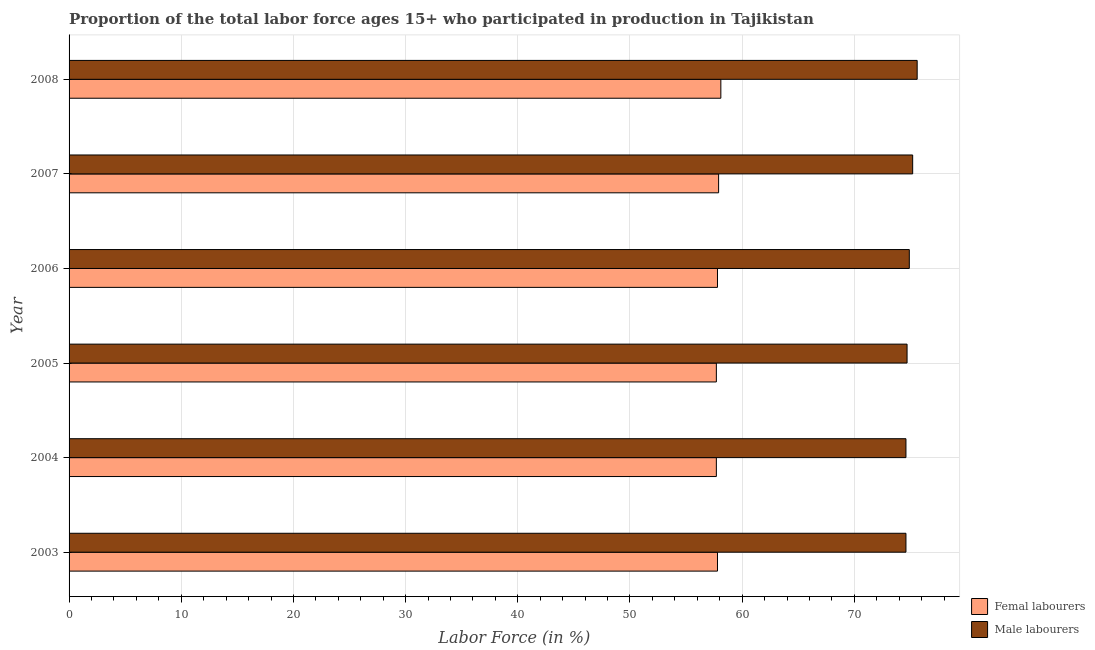How many different coloured bars are there?
Your response must be concise. 2. How many bars are there on the 5th tick from the bottom?
Offer a terse response. 2. In how many cases, is the number of bars for a given year not equal to the number of legend labels?
Provide a succinct answer. 0. What is the percentage of male labour force in 2003?
Give a very brief answer. 74.6. Across all years, what is the maximum percentage of male labour force?
Keep it short and to the point. 75.6. Across all years, what is the minimum percentage of female labor force?
Ensure brevity in your answer.  57.7. What is the total percentage of female labor force in the graph?
Provide a short and direct response. 347. What is the difference between the percentage of male labour force in 2005 and that in 2008?
Give a very brief answer. -0.9. What is the difference between the percentage of female labor force in 2004 and the percentage of male labour force in 2008?
Provide a succinct answer. -17.9. What is the average percentage of male labour force per year?
Your answer should be compact. 74.93. What is the ratio of the percentage of male labour force in 2006 to that in 2008?
Your answer should be compact. 0.99. What is the difference between the highest and the second highest percentage of female labor force?
Ensure brevity in your answer.  0.2. What does the 2nd bar from the top in 2008 represents?
Keep it short and to the point. Femal labourers. What does the 2nd bar from the bottom in 2005 represents?
Your response must be concise. Male labourers. How many years are there in the graph?
Provide a short and direct response. 6. What is the difference between two consecutive major ticks on the X-axis?
Your answer should be very brief. 10. Are the values on the major ticks of X-axis written in scientific E-notation?
Your answer should be compact. No. Does the graph contain grids?
Offer a very short reply. Yes. Where does the legend appear in the graph?
Provide a short and direct response. Bottom right. What is the title of the graph?
Make the answer very short. Proportion of the total labor force ages 15+ who participated in production in Tajikistan. What is the Labor Force (in %) in Femal labourers in 2003?
Offer a terse response. 57.8. What is the Labor Force (in %) of Male labourers in 2003?
Your response must be concise. 74.6. What is the Labor Force (in %) in Femal labourers in 2004?
Provide a succinct answer. 57.7. What is the Labor Force (in %) of Male labourers in 2004?
Your answer should be very brief. 74.6. What is the Labor Force (in %) in Femal labourers in 2005?
Your response must be concise. 57.7. What is the Labor Force (in %) of Male labourers in 2005?
Make the answer very short. 74.7. What is the Labor Force (in %) in Femal labourers in 2006?
Give a very brief answer. 57.8. What is the Labor Force (in %) of Male labourers in 2006?
Your response must be concise. 74.9. What is the Labor Force (in %) of Femal labourers in 2007?
Keep it short and to the point. 57.9. What is the Labor Force (in %) in Male labourers in 2007?
Offer a very short reply. 75.2. What is the Labor Force (in %) of Femal labourers in 2008?
Keep it short and to the point. 58.1. What is the Labor Force (in %) in Male labourers in 2008?
Your answer should be compact. 75.6. Across all years, what is the maximum Labor Force (in %) in Femal labourers?
Offer a terse response. 58.1. Across all years, what is the maximum Labor Force (in %) in Male labourers?
Ensure brevity in your answer.  75.6. Across all years, what is the minimum Labor Force (in %) in Femal labourers?
Your answer should be compact. 57.7. Across all years, what is the minimum Labor Force (in %) of Male labourers?
Ensure brevity in your answer.  74.6. What is the total Labor Force (in %) in Femal labourers in the graph?
Offer a terse response. 347. What is the total Labor Force (in %) in Male labourers in the graph?
Your answer should be very brief. 449.6. What is the difference between the Labor Force (in %) in Femal labourers in 2003 and that in 2004?
Your answer should be very brief. 0.1. What is the difference between the Labor Force (in %) of Male labourers in 2003 and that in 2004?
Offer a very short reply. 0. What is the difference between the Labor Force (in %) of Femal labourers in 2003 and that in 2005?
Provide a short and direct response. 0.1. What is the difference between the Labor Force (in %) of Male labourers in 2003 and that in 2005?
Offer a very short reply. -0.1. What is the difference between the Labor Force (in %) of Femal labourers in 2003 and that in 2006?
Give a very brief answer. 0. What is the difference between the Labor Force (in %) in Male labourers in 2003 and that in 2006?
Keep it short and to the point. -0.3. What is the difference between the Labor Force (in %) of Male labourers in 2003 and that in 2008?
Keep it short and to the point. -1. What is the difference between the Labor Force (in %) of Male labourers in 2004 and that in 2006?
Keep it short and to the point. -0.3. What is the difference between the Labor Force (in %) in Femal labourers in 2004 and that in 2007?
Give a very brief answer. -0.2. What is the difference between the Labor Force (in %) of Male labourers in 2004 and that in 2008?
Your answer should be compact. -1. What is the difference between the Labor Force (in %) of Male labourers in 2005 and that in 2006?
Make the answer very short. -0.2. What is the difference between the Labor Force (in %) of Male labourers in 2006 and that in 2008?
Offer a terse response. -0.7. What is the difference between the Labor Force (in %) in Male labourers in 2007 and that in 2008?
Your response must be concise. -0.4. What is the difference between the Labor Force (in %) of Femal labourers in 2003 and the Labor Force (in %) of Male labourers in 2004?
Provide a short and direct response. -16.8. What is the difference between the Labor Force (in %) in Femal labourers in 2003 and the Labor Force (in %) in Male labourers in 2005?
Keep it short and to the point. -16.9. What is the difference between the Labor Force (in %) in Femal labourers in 2003 and the Labor Force (in %) in Male labourers in 2006?
Your response must be concise. -17.1. What is the difference between the Labor Force (in %) of Femal labourers in 2003 and the Labor Force (in %) of Male labourers in 2007?
Offer a very short reply. -17.4. What is the difference between the Labor Force (in %) in Femal labourers in 2003 and the Labor Force (in %) in Male labourers in 2008?
Make the answer very short. -17.8. What is the difference between the Labor Force (in %) of Femal labourers in 2004 and the Labor Force (in %) of Male labourers in 2006?
Offer a very short reply. -17.2. What is the difference between the Labor Force (in %) of Femal labourers in 2004 and the Labor Force (in %) of Male labourers in 2007?
Your response must be concise. -17.5. What is the difference between the Labor Force (in %) in Femal labourers in 2004 and the Labor Force (in %) in Male labourers in 2008?
Offer a very short reply. -17.9. What is the difference between the Labor Force (in %) in Femal labourers in 2005 and the Labor Force (in %) in Male labourers in 2006?
Give a very brief answer. -17.2. What is the difference between the Labor Force (in %) in Femal labourers in 2005 and the Labor Force (in %) in Male labourers in 2007?
Provide a succinct answer. -17.5. What is the difference between the Labor Force (in %) in Femal labourers in 2005 and the Labor Force (in %) in Male labourers in 2008?
Give a very brief answer. -17.9. What is the difference between the Labor Force (in %) of Femal labourers in 2006 and the Labor Force (in %) of Male labourers in 2007?
Provide a succinct answer. -17.4. What is the difference between the Labor Force (in %) of Femal labourers in 2006 and the Labor Force (in %) of Male labourers in 2008?
Ensure brevity in your answer.  -17.8. What is the difference between the Labor Force (in %) of Femal labourers in 2007 and the Labor Force (in %) of Male labourers in 2008?
Keep it short and to the point. -17.7. What is the average Labor Force (in %) in Femal labourers per year?
Provide a succinct answer. 57.83. What is the average Labor Force (in %) of Male labourers per year?
Your answer should be very brief. 74.93. In the year 2003, what is the difference between the Labor Force (in %) of Femal labourers and Labor Force (in %) of Male labourers?
Keep it short and to the point. -16.8. In the year 2004, what is the difference between the Labor Force (in %) in Femal labourers and Labor Force (in %) in Male labourers?
Your answer should be very brief. -16.9. In the year 2006, what is the difference between the Labor Force (in %) in Femal labourers and Labor Force (in %) in Male labourers?
Give a very brief answer. -17.1. In the year 2007, what is the difference between the Labor Force (in %) in Femal labourers and Labor Force (in %) in Male labourers?
Provide a short and direct response. -17.3. In the year 2008, what is the difference between the Labor Force (in %) of Femal labourers and Labor Force (in %) of Male labourers?
Give a very brief answer. -17.5. What is the ratio of the Labor Force (in %) of Femal labourers in 2003 to that in 2004?
Ensure brevity in your answer.  1. What is the ratio of the Labor Force (in %) in Femal labourers in 2003 to that in 2005?
Make the answer very short. 1. What is the ratio of the Labor Force (in %) of Male labourers in 2003 to that in 2005?
Provide a short and direct response. 1. What is the ratio of the Labor Force (in %) of Femal labourers in 2003 to that in 2006?
Offer a terse response. 1. What is the ratio of the Labor Force (in %) of Male labourers in 2003 to that in 2006?
Your answer should be very brief. 1. What is the ratio of the Labor Force (in %) in Femal labourers in 2003 to that in 2007?
Offer a very short reply. 1. What is the ratio of the Labor Force (in %) in Male labourers in 2003 to that in 2007?
Your response must be concise. 0.99. What is the ratio of the Labor Force (in %) in Femal labourers in 2003 to that in 2008?
Provide a succinct answer. 0.99. What is the ratio of the Labor Force (in %) in Femal labourers in 2004 to that in 2006?
Your answer should be very brief. 1. What is the ratio of the Labor Force (in %) in Male labourers in 2004 to that in 2006?
Your answer should be very brief. 1. What is the ratio of the Labor Force (in %) of Femal labourers in 2004 to that in 2008?
Your answer should be very brief. 0.99. What is the ratio of the Labor Force (in %) of Femal labourers in 2005 to that in 2006?
Your answer should be compact. 1. What is the ratio of the Labor Force (in %) of Male labourers in 2005 to that in 2006?
Offer a very short reply. 1. What is the ratio of the Labor Force (in %) of Femal labourers in 2005 to that in 2007?
Provide a succinct answer. 1. What is the ratio of the Labor Force (in %) in Femal labourers in 2006 to that in 2007?
Offer a terse response. 1. What is the ratio of the Labor Force (in %) of Male labourers in 2006 to that in 2008?
Make the answer very short. 0.99. What is the ratio of the Labor Force (in %) in Male labourers in 2007 to that in 2008?
Your answer should be very brief. 0.99. What is the difference between the highest and the second highest Labor Force (in %) in Femal labourers?
Make the answer very short. 0.2. What is the difference between the highest and the lowest Labor Force (in %) in Male labourers?
Your answer should be very brief. 1. 